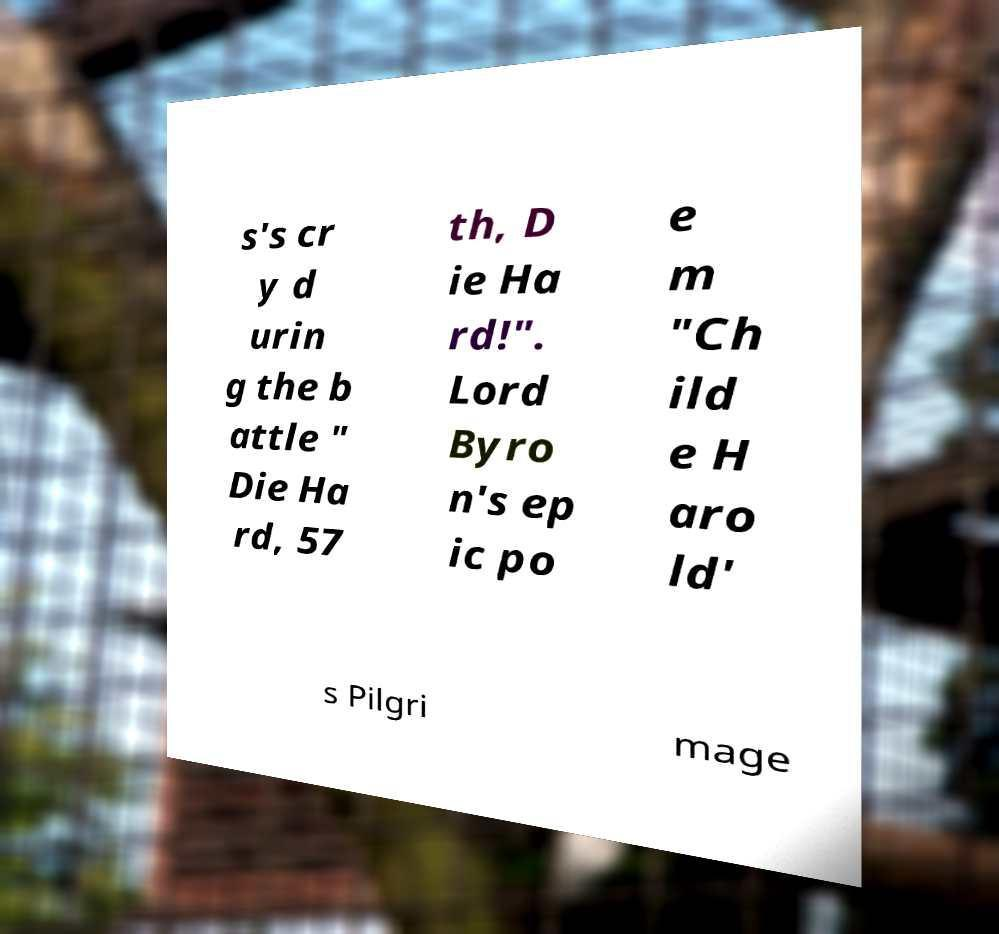What messages or text are displayed in this image? I need them in a readable, typed format. s's cr y d urin g the b attle " Die Ha rd, 57 th, D ie Ha rd!". Lord Byro n's ep ic po e m "Ch ild e H aro ld' s Pilgri mage 